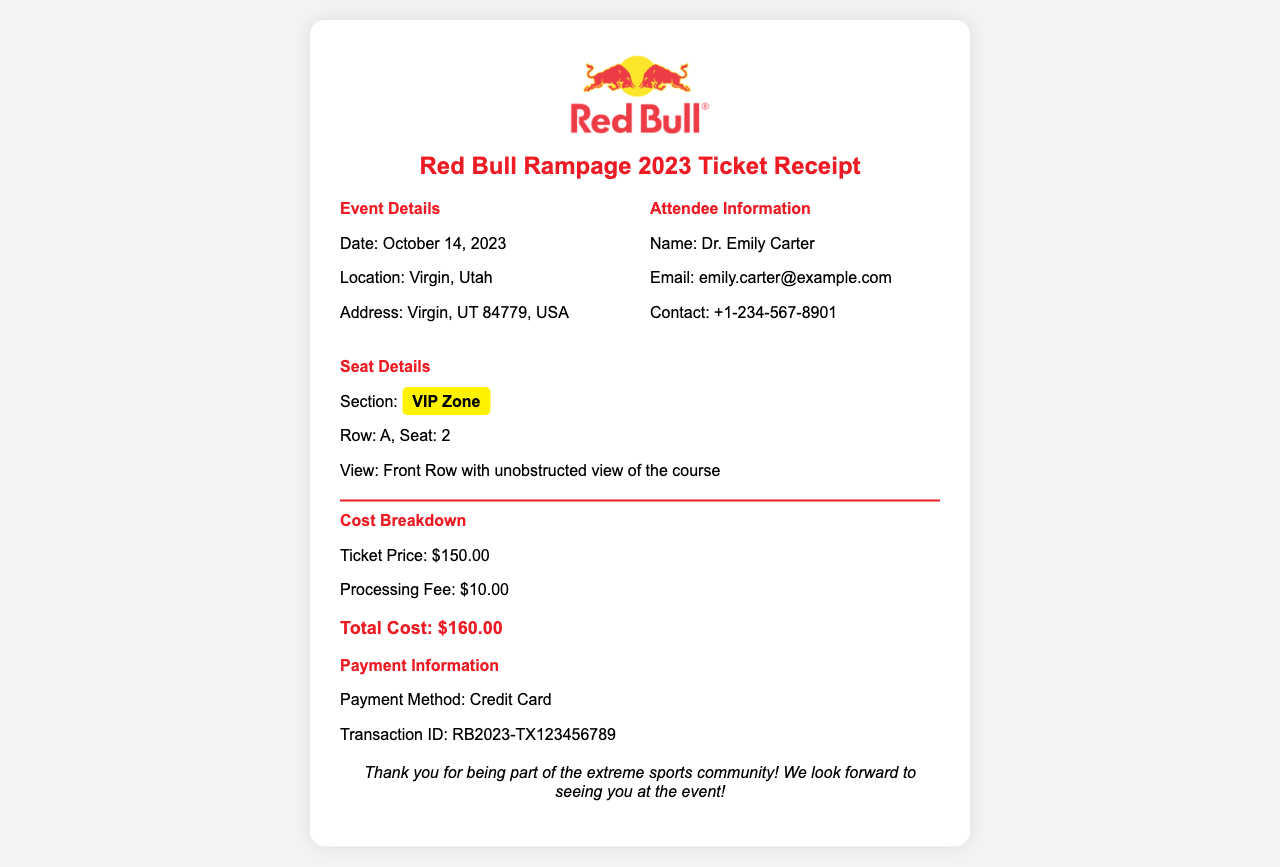what is the event date? The event date is clearly stated in the document, which is October 14, 2023.
Answer: October 14, 2023 what is the total cost of the ticket? The total cost of the ticket is mentioned in the cost details section as $160.00.
Answer: $160.00 who is the ticket holder? The ticket holder's name is provided under attendee information as Dr. Emily Carter.
Answer: Dr. Emily Carter what section and seat number is assigned? The section and seat number are outlined in the seat details section, which states VIP Zone, Row A, Seat 2.
Answer: VIP Zone, Row A, Seat 2 what is the processing fee? The processing fee is indicated in the cost breakdown section as $10.00.
Answer: $10.00 where is the event location? The event location is specified in the document as Virgin, Utah.
Answer: Virgin, Utah what type of payment method was used? The payment method is discussed in the payment information section, which notes Credit Card.
Answer: Credit Card what is the view from the assigned seat? The view from the assigned seat is described as Front Row with unobstructed view of the course.
Answer: Front Row with unobstructed view of the course what is the transaction ID for the payment? The transaction ID for the payment is outlined under payment information as RB2023-TX123456789.
Answer: RB2023-TX123456789 